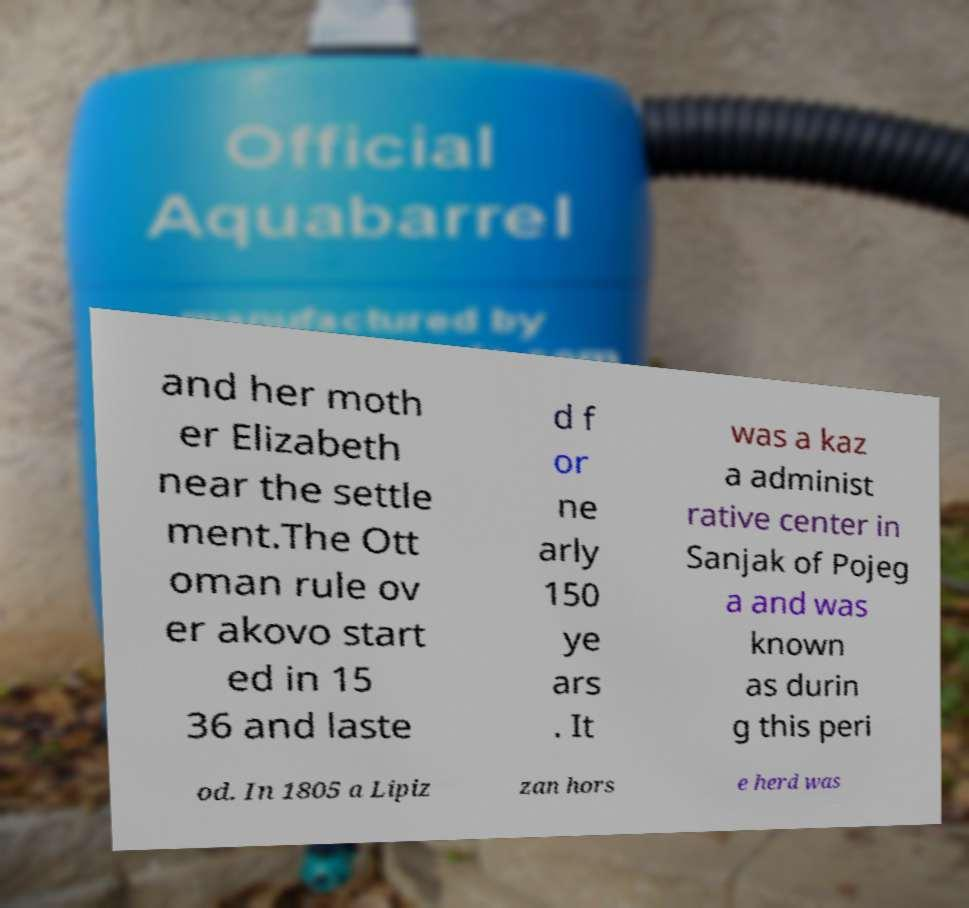Could you extract and type out the text from this image? and her moth er Elizabeth near the settle ment.The Ott oman rule ov er akovo start ed in 15 36 and laste d f or ne arly 150 ye ars . It was a kaz a administ rative center in Sanjak of Pojeg a and was known as durin g this peri od. In 1805 a Lipiz zan hors e herd was 